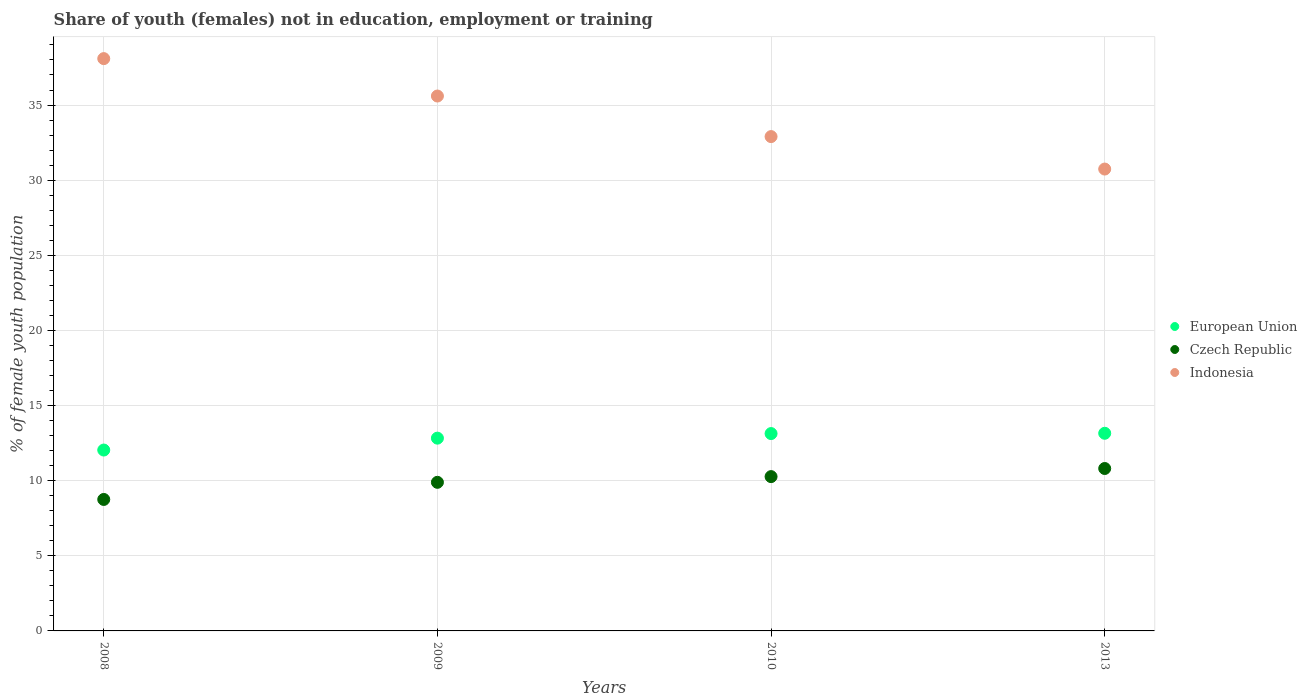What is the percentage of unemployed female population in in European Union in 2013?
Keep it short and to the point. 13.15. Across all years, what is the maximum percentage of unemployed female population in in European Union?
Your answer should be compact. 13.15. Across all years, what is the minimum percentage of unemployed female population in in Czech Republic?
Offer a very short reply. 8.75. What is the total percentage of unemployed female population in in European Union in the graph?
Give a very brief answer. 51.16. What is the difference between the percentage of unemployed female population in in European Union in 2009 and that in 2013?
Offer a very short reply. -0.32. What is the difference between the percentage of unemployed female population in in European Union in 2013 and the percentage of unemployed female population in in Indonesia in 2009?
Provide a succinct answer. -22.45. What is the average percentage of unemployed female population in in Indonesia per year?
Provide a succinct answer. 34.33. In the year 2013, what is the difference between the percentage of unemployed female population in in Indonesia and percentage of unemployed female population in in European Union?
Offer a terse response. 17.59. In how many years, is the percentage of unemployed female population in in Czech Republic greater than 2 %?
Provide a succinct answer. 4. What is the ratio of the percentage of unemployed female population in in Indonesia in 2009 to that in 2013?
Provide a short and direct response. 1.16. Is the difference between the percentage of unemployed female population in in Indonesia in 2009 and 2010 greater than the difference between the percentage of unemployed female population in in European Union in 2009 and 2010?
Offer a very short reply. Yes. What is the difference between the highest and the second highest percentage of unemployed female population in in Indonesia?
Your answer should be very brief. 2.49. What is the difference between the highest and the lowest percentage of unemployed female population in in European Union?
Give a very brief answer. 1.12. Is it the case that in every year, the sum of the percentage of unemployed female population in in Indonesia and percentage of unemployed female population in in European Union  is greater than the percentage of unemployed female population in in Czech Republic?
Give a very brief answer. Yes. Does the percentage of unemployed female population in in Czech Republic monotonically increase over the years?
Your answer should be compact. Yes. Is the percentage of unemployed female population in in Indonesia strictly less than the percentage of unemployed female population in in Czech Republic over the years?
Make the answer very short. No. What is the difference between two consecutive major ticks on the Y-axis?
Provide a succinct answer. 5. Does the graph contain any zero values?
Your answer should be compact. No. Where does the legend appear in the graph?
Your answer should be compact. Center right. What is the title of the graph?
Your response must be concise. Share of youth (females) not in education, employment or training. What is the label or title of the X-axis?
Offer a very short reply. Years. What is the label or title of the Y-axis?
Ensure brevity in your answer.  % of female youth population. What is the % of female youth population of European Union in 2008?
Ensure brevity in your answer.  12.04. What is the % of female youth population of Czech Republic in 2008?
Your response must be concise. 8.75. What is the % of female youth population of Indonesia in 2008?
Your answer should be compact. 38.09. What is the % of female youth population in European Union in 2009?
Ensure brevity in your answer.  12.83. What is the % of female youth population in Czech Republic in 2009?
Offer a very short reply. 9.89. What is the % of female youth population of Indonesia in 2009?
Keep it short and to the point. 35.6. What is the % of female youth population of European Union in 2010?
Offer a terse response. 13.13. What is the % of female youth population in Czech Republic in 2010?
Your answer should be very brief. 10.27. What is the % of female youth population in Indonesia in 2010?
Give a very brief answer. 32.9. What is the % of female youth population of European Union in 2013?
Provide a succinct answer. 13.15. What is the % of female youth population of Czech Republic in 2013?
Your answer should be compact. 10.81. What is the % of female youth population of Indonesia in 2013?
Your response must be concise. 30.74. Across all years, what is the maximum % of female youth population in European Union?
Give a very brief answer. 13.15. Across all years, what is the maximum % of female youth population in Czech Republic?
Keep it short and to the point. 10.81. Across all years, what is the maximum % of female youth population of Indonesia?
Make the answer very short. 38.09. Across all years, what is the minimum % of female youth population in European Union?
Provide a succinct answer. 12.04. Across all years, what is the minimum % of female youth population in Czech Republic?
Your answer should be very brief. 8.75. Across all years, what is the minimum % of female youth population of Indonesia?
Make the answer very short. 30.74. What is the total % of female youth population in European Union in the graph?
Offer a very short reply. 51.16. What is the total % of female youth population of Czech Republic in the graph?
Offer a very short reply. 39.72. What is the total % of female youth population in Indonesia in the graph?
Your response must be concise. 137.33. What is the difference between the % of female youth population of European Union in 2008 and that in 2009?
Your answer should be compact. -0.79. What is the difference between the % of female youth population of Czech Republic in 2008 and that in 2009?
Give a very brief answer. -1.14. What is the difference between the % of female youth population in Indonesia in 2008 and that in 2009?
Keep it short and to the point. 2.49. What is the difference between the % of female youth population in European Union in 2008 and that in 2010?
Offer a very short reply. -1.1. What is the difference between the % of female youth population of Czech Republic in 2008 and that in 2010?
Offer a terse response. -1.52. What is the difference between the % of female youth population in Indonesia in 2008 and that in 2010?
Give a very brief answer. 5.19. What is the difference between the % of female youth population of European Union in 2008 and that in 2013?
Offer a very short reply. -1.12. What is the difference between the % of female youth population of Czech Republic in 2008 and that in 2013?
Ensure brevity in your answer.  -2.06. What is the difference between the % of female youth population of Indonesia in 2008 and that in 2013?
Ensure brevity in your answer.  7.35. What is the difference between the % of female youth population of European Union in 2009 and that in 2010?
Keep it short and to the point. -0.3. What is the difference between the % of female youth population in Czech Republic in 2009 and that in 2010?
Keep it short and to the point. -0.38. What is the difference between the % of female youth population of Indonesia in 2009 and that in 2010?
Your answer should be compact. 2.7. What is the difference between the % of female youth population in European Union in 2009 and that in 2013?
Provide a succinct answer. -0.32. What is the difference between the % of female youth population in Czech Republic in 2009 and that in 2013?
Your response must be concise. -0.92. What is the difference between the % of female youth population of Indonesia in 2009 and that in 2013?
Your response must be concise. 4.86. What is the difference between the % of female youth population in European Union in 2010 and that in 2013?
Give a very brief answer. -0.02. What is the difference between the % of female youth population in Czech Republic in 2010 and that in 2013?
Provide a succinct answer. -0.54. What is the difference between the % of female youth population of Indonesia in 2010 and that in 2013?
Your response must be concise. 2.16. What is the difference between the % of female youth population in European Union in 2008 and the % of female youth population in Czech Republic in 2009?
Give a very brief answer. 2.15. What is the difference between the % of female youth population in European Union in 2008 and the % of female youth population in Indonesia in 2009?
Provide a succinct answer. -23.56. What is the difference between the % of female youth population in Czech Republic in 2008 and the % of female youth population in Indonesia in 2009?
Give a very brief answer. -26.85. What is the difference between the % of female youth population in European Union in 2008 and the % of female youth population in Czech Republic in 2010?
Your answer should be very brief. 1.77. What is the difference between the % of female youth population in European Union in 2008 and the % of female youth population in Indonesia in 2010?
Keep it short and to the point. -20.86. What is the difference between the % of female youth population of Czech Republic in 2008 and the % of female youth population of Indonesia in 2010?
Your response must be concise. -24.15. What is the difference between the % of female youth population in European Union in 2008 and the % of female youth population in Czech Republic in 2013?
Your answer should be very brief. 1.23. What is the difference between the % of female youth population in European Union in 2008 and the % of female youth population in Indonesia in 2013?
Provide a short and direct response. -18.7. What is the difference between the % of female youth population of Czech Republic in 2008 and the % of female youth population of Indonesia in 2013?
Ensure brevity in your answer.  -21.99. What is the difference between the % of female youth population of European Union in 2009 and the % of female youth population of Czech Republic in 2010?
Ensure brevity in your answer.  2.56. What is the difference between the % of female youth population in European Union in 2009 and the % of female youth population in Indonesia in 2010?
Provide a succinct answer. -20.07. What is the difference between the % of female youth population of Czech Republic in 2009 and the % of female youth population of Indonesia in 2010?
Provide a succinct answer. -23.01. What is the difference between the % of female youth population of European Union in 2009 and the % of female youth population of Czech Republic in 2013?
Offer a terse response. 2.02. What is the difference between the % of female youth population of European Union in 2009 and the % of female youth population of Indonesia in 2013?
Your response must be concise. -17.91. What is the difference between the % of female youth population in Czech Republic in 2009 and the % of female youth population in Indonesia in 2013?
Provide a succinct answer. -20.85. What is the difference between the % of female youth population in European Union in 2010 and the % of female youth population in Czech Republic in 2013?
Your answer should be compact. 2.32. What is the difference between the % of female youth population of European Union in 2010 and the % of female youth population of Indonesia in 2013?
Offer a terse response. -17.61. What is the difference between the % of female youth population in Czech Republic in 2010 and the % of female youth population in Indonesia in 2013?
Offer a very short reply. -20.47. What is the average % of female youth population of European Union per year?
Ensure brevity in your answer.  12.79. What is the average % of female youth population of Czech Republic per year?
Your answer should be compact. 9.93. What is the average % of female youth population in Indonesia per year?
Your answer should be very brief. 34.33. In the year 2008, what is the difference between the % of female youth population of European Union and % of female youth population of Czech Republic?
Provide a succinct answer. 3.29. In the year 2008, what is the difference between the % of female youth population in European Union and % of female youth population in Indonesia?
Offer a very short reply. -26.05. In the year 2008, what is the difference between the % of female youth population of Czech Republic and % of female youth population of Indonesia?
Keep it short and to the point. -29.34. In the year 2009, what is the difference between the % of female youth population of European Union and % of female youth population of Czech Republic?
Offer a terse response. 2.94. In the year 2009, what is the difference between the % of female youth population of European Union and % of female youth population of Indonesia?
Your response must be concise. -22.77. In the year 2009, what is the difference between the % of female youth population of Czech Republic and % of female youth population of Indonesia?
Offer a very short reply. -25.71. In the year 2010, what is the difference between the % of female youth population of European Union and % of female youth population of Czech Republic?
Your answer should be very brief. 2.86. In the year 2010, what is the difference between the % of female youth population in European Union and % of female youth population in Indonesia?
Offer a terse response. -19.77. In the year 2010, what is the difference between the % of female youth population in Czech Republic and % of female youth population in Indonesia?
Give a very brief answer. -22.63. In the year 2013, what is the difference between the % of female youth population in European Union and % of female youth population in Czech Republic?
Provide a short and direct response. 2.34. In the year 2013, what is the difference between the % of female youth population of European Union and % of female youth population of Indonesia?
Provide a succinct answer. -17.59. In the year 2013, what is the difference between the % of female youth population in Czech Republic and % of female youth population in Indonesia?
Give a very brief answer. -19.93. What is the ratio of the % of female youth population of European Union in 2008 to that in 2009?
Provide a short and direct response. 0.94. What is the ratio of the % of female youth population of Czech Republic in 2008 to that in 2009?
Offer a very short reply. 0.88. What is the ratio of the % of female youth population of Indonesia in 2008 to that in 2009?
Keep it short and to the point. 1.07. What is the ratio of the % of female youth population in European Union in 2008 to that in 2010?
Your answer should be very brief. 0.92. What is the ratio of the % of female youth population of Czech Republic in 2008 to that in 2010?
Your answer should be very brief. 0.85. What is the ratio of the % of female youth population in Indonesia in 2008 to that in 2010?
Offer a terse response. 1.16. What is the ratio of the % of female youth population of European Union in 2008 to that in 2013?
Give a very brief answer. 0.92. What is the ratio of the % of female youth population in Czech Republic in 2008 to that in 2013?
Provide a short and direct response. 0.81. What is the ratio of the % of female youth population of Indonesia in 2008 to that in 2013?
Offer a terse response. 1.24. What is the ratio of the % of female youth population of European Union in 2009 to that in 2010?
Your answer should be compact. 0.98. What is the ratio of the % of female youth population of Czech Republic in 2009 to that in 2010?
Your answer should be compact. 0.96. What is the ratio of the % of female youth population of Indonesia in 2009 to that in 2010?
Ensure brevity in your answer.  1.08. What is the ratio of the % of female youth population in European Union in 2009 to that in 2013?
Your answer should be very brief. 0.98. What is the ratio of the % of female youth population in Czech Republic in 2009 to that in 2013?
Ensure brevity in your answer.  0.91. What is the ratio of the % of female youth population of Indonesia in 2009 to that in 2013?
Your answer should be very brief. 1.16. What is the ratio of the % of female youth population in Czech Republic in 2010 to that in 2013?
Provide a succinct answer. 0.95. What is the ratio of the % of female youth population in Indonesia in 2010 to that in 2013?
Keep it short and to the point. 1.07. What is the difference between the highest and the second highest % of female youth population of European Union?
Your answer should be very brief. 0.02. What is the difference between the highest and the second highest % of female youth population in Czech Republic?
Your answer should be very brief. 0.54. What is the difference between the highest and the second highest % of female youth population in Indonesia?
Offer a very short reply. 2.49. What is the difference between the highest and the lowest % of female youth population in European Union?
Provide a succinct answer. 1.12. What is the difference between the highest and the lowest % of female youth population of Czech Republic?
Your answer should be compact. 2.06. What is the difference between the highest and the lowest % of female youth population in Indonesia?
Keep it short and to the point. 7.35. 